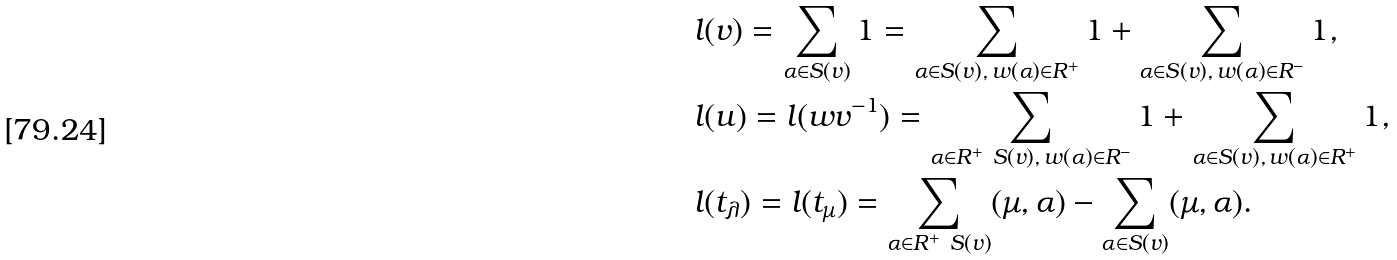<formula> <loc_0><loc_0><loc_500><loc_500>& l ( v ) = \sum _ { \alpha \in S ( v ) } 1 = \sum _ { \alpha \in S ( v ) , \, w ( \alpha ) \in R ^ { + } } 1 + \sum _ { \alpha \in S ( v ) , \, w ( \alpha ) \in R ^ { - } } 1 , \\ & l ( u ) = l ( w v ^ { - 1 } ) = \sum _ { \alpha \in R ^ { + } \ S ( v ) , \, w ( \alpha ) \in R ^ { - } } 1 + \sum _ { \alpha \in S ( v ) , \, w ( \alpha ) \in R ^ { + } } 1 , \\ & l ( t _ { \lambda } ) = l ( t _ { \mu } ) = \sum _ { \alpha \in R ^ { + } \ S ( v ) } ( \mu , \alpha ) - \sum _ { \alpha \in S ( v ) } ( \mu , \alpha ) .</formula> 